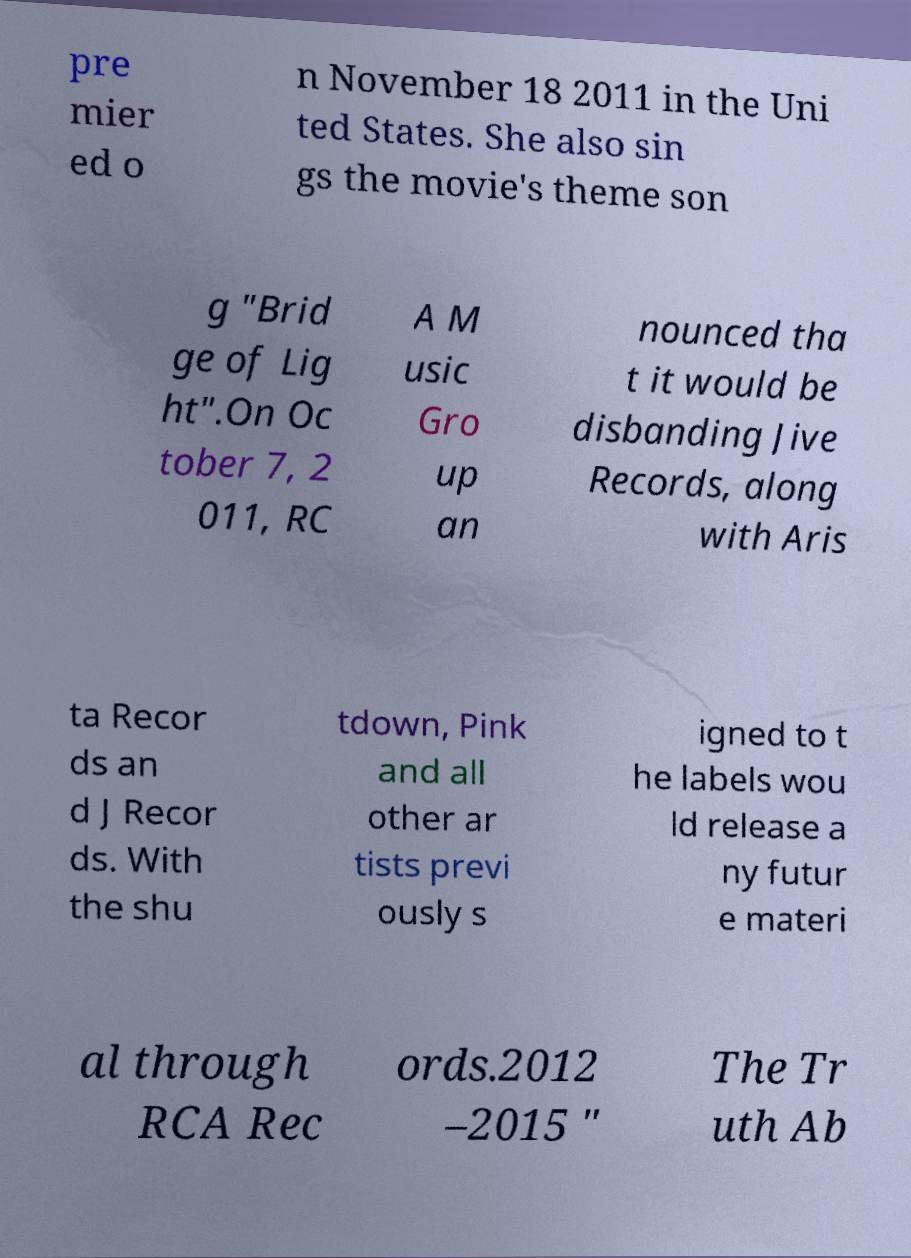There's text embedded in this image that I need extracted. Can you transcribe it verbatim? pre mier ed o n November 18 2011 in the Uni ted States. She also sin gs the movie's theme son g "Brid ge of Lig ht".On Oc tober 7, 2 011, RC A M usic Gro up an nounced tha t it would be disbanding Jive Records, along with Aris ta Recor ds an d J Recor ds. With the shu tdown, Pink and all other ar tists previ ously s igned to t he labels wou ld release a ny futur e materi al through RCA Rec ords.2012 –2015 " The Tr uth Ab 